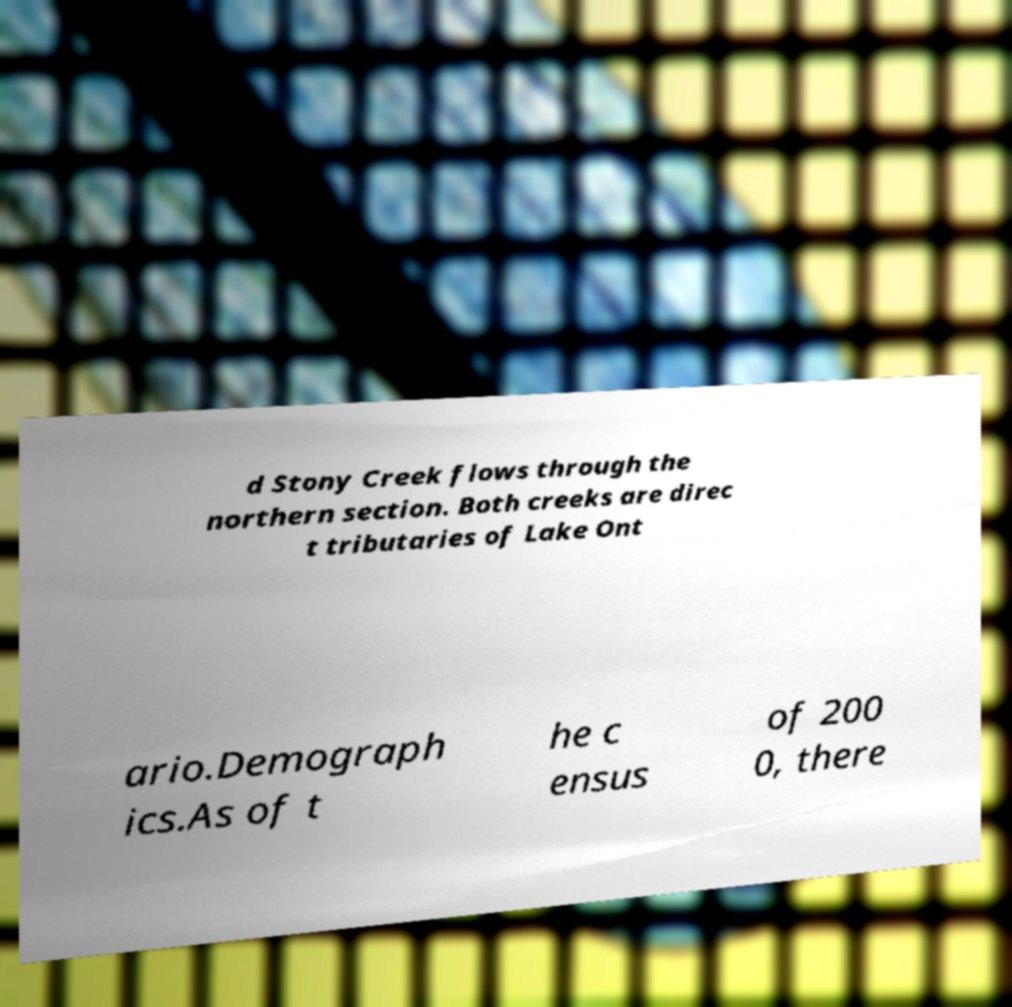Can you accurately transcribe the text from the provided image for me? d Stony Creek flows through the northern section. Both creeks are direc t tributaries of Lake Ont ario.Demograph ics.As of t he c ensus of 200 0, there 